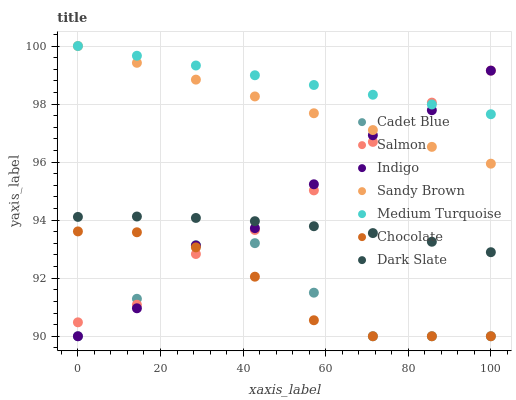Does Cadet Blue have the minimum area under the curve?
Answer yes or no. Yes. Does Medium Turquoise have the maximum area under the curve?
Answer yes or no. Yes. Does Indigo have the minimum area under the curve?
Answer yes or no. No. Does Indigo have the maximum area under the curve?
Answer yes or no. No. Is Medium Turquoise the smoothest?
Answer yes or no. Yes. Is Cadet Blue the roughest?
Answer yes or no. Yes. Is Indigo the smoothest?
Answer yes or no. No. Is Indigo the roughest?
Answer yes or no. No. Does Cadet Blue have the lowest value?
Answer yes or no. Yes. Does Salmon have the lowest value?
Answer yes or no. No. Does Sandy Brown have the highest value?
Answer yes or no. Yes. Does Indigo have the highest value?
Answer yes or no. No. Is Cadet Blue less than Dark Slate?
Answer yes or no. Yes. Is Sandy Brown greater than Cadet Blue?
Answer yes or no. Yes. Does Medium Turquoise intersect Indigo?
Answer yes or no. Yes. Is Medium Turquoise less than Indigo?
Answer yes or no. No. Is Medium Turquoise greater than Indigo?
Answer yes or no. No. Does Cadet Blue intersect Dark Slate?
Answer yes or no. No. 